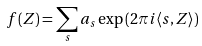<formula> <loc_0><loc_0><loc_500><loc_500>f ( Z ) = \sum _ { s } a _ { s } \exp \left ( { 2 \pi i \langle s , Z \rangle } \right )</formula> 